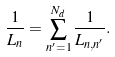Convert formula to latex. <formula><loc_0><loc_0><loc_500><loc_500>\frac { 1 } { L _ { n } } = \sum _ { n ^ { \prime } = 1 } ^ { N _ { d } } \frac { 1 } { L _ { n , n ^ { \prime } } } .</formula> 